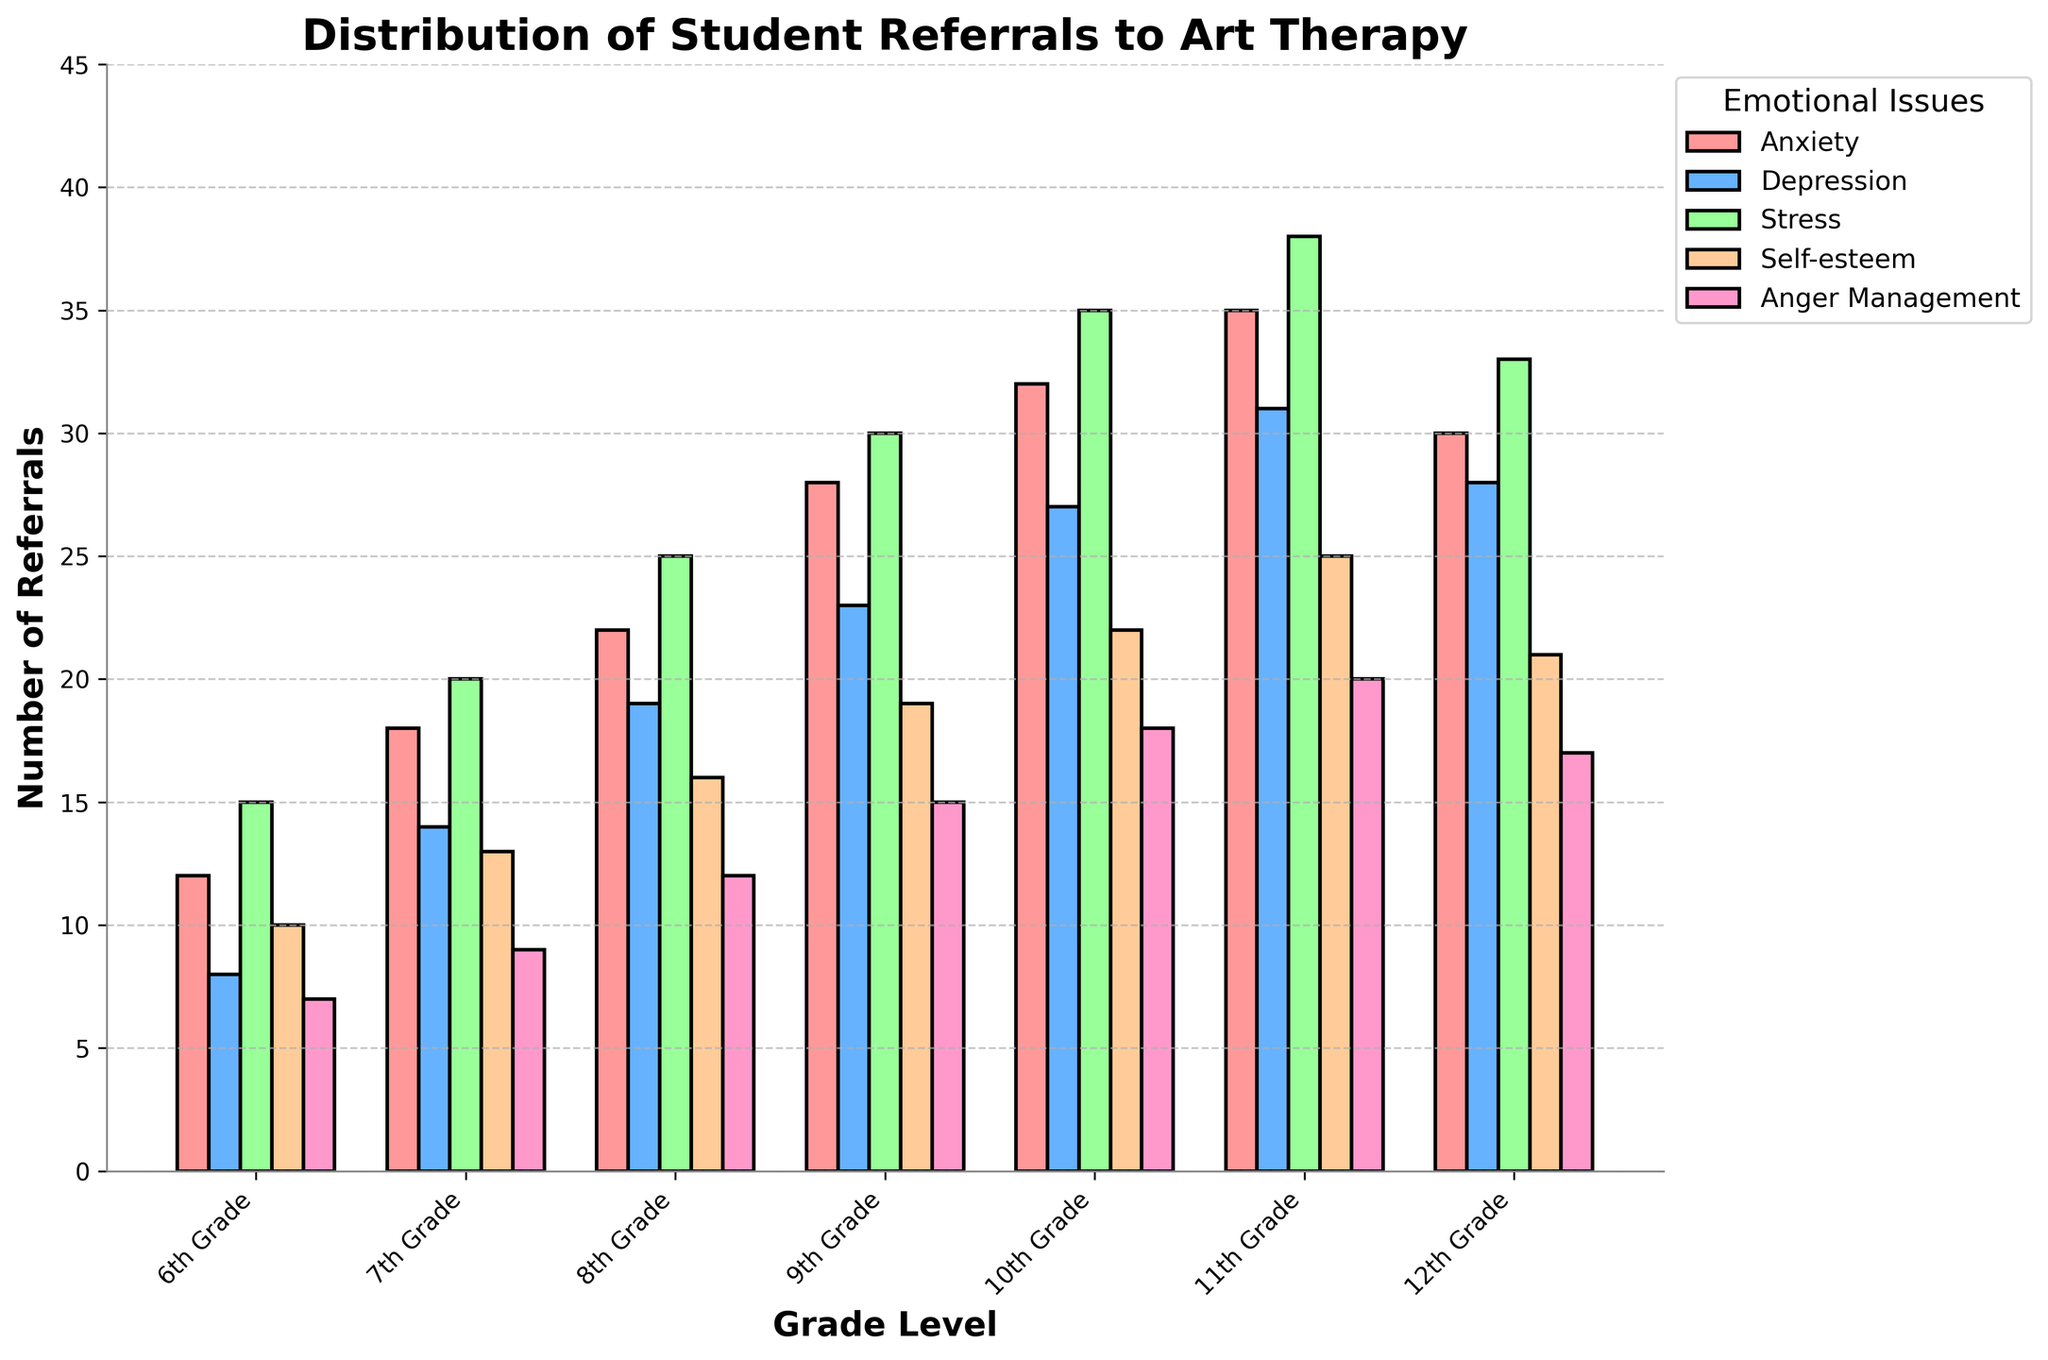Which grade level has the highest number of referrals for anger management? Look at the bar heights for "Anger Management" across all grade levels and identify the highest one. The 11th Grade has the tallest bar for anger management.
Answer: 11th Grade How many more referrals are there for stress in 10th grade compared to 6th grade? Note the values for stress referrals in 10th grade (35) and 6th grade (15). The difference is calculated as 35 - 15 = 20.
Answer: 20 Which emotional issue has the most referrals across all grades? Sum up the number of referrals for each emotional issue across all grades. The totals are: Anxiety (177), Depression (150), Stress (196), Self-esteem (126), Anger Management (98). Stress has the most referrals.
Answer: Stress Which grade level has the smallest difference in referrals between anxiety and depression? Calculate the absolute differences for each grade level: 6th Grade (4), 7th Grade (4), 8th Grade (3), 9th Grade (5), 10th Grade (5), 11th Grade (4), 12th Grade (2). The 12th Grade has the smallest difference.
Answer: 12th Grade What is the average number of referrals per emotional issue in the 9th grade? Sum up the referrals for all emotional issues in the 9th grade (28+23+30+19+15 = 115), then divide by the number of issues (5). The average is 115/5 = 23.
Answer: 23 In which grade does self-esteem have nearly half as many referrals as stress? Check the referrals for self-esteem and stress in each grade for ratio comparison. In 8th grade, self-esteem (16) is nearly half of stress (25).
Answer: 8th Grade Which issue has a color-coded bar that is green? Identify the issue represented by the green-colored bars by looking at the legend. The green color corresponds to "Stress".
Answer: Stress What is the median number of referrals for anxiety across all grades? Organize the anxiety referrals: [12, 18, 22, 28, 30, 32, 35]. The median value (middle value) is 28.
Answer: 28 Are depression referrals higher in 11th grade or 12th grade? Compare the depression referrals in 11th grade (31) and 12th grade (28). The 11th grade has higher referrals.
Answer: 11th Grade What is the total number of referrals for 7th grade for all emotional issues combined? Sum up the referrals in 7th grade for all issues: Anxiety (18), Depression (14), Stress (20), Self-esteem (13), Anger Management (9). The total is 18+14+20+13+9 = 74.
Answer: 74 